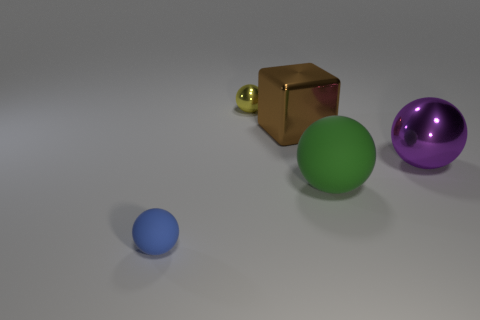There is a yellow sphere that is made of the same material as the large brown object; what is its size?
Your answer should be compact. Small. There is a purple object that is the same size as the brown object; what is it made of?
Make the answer very short. Metal. How many objects are big matte blocks or big metal objects to the right of the large matte ball?
Offer a terse response. 1. Is there another thing of the same shape as the tiny metal thing?
Ensure brevity in your answer.  Yes. There is a thing that is left of the tiny ball behind the tiny blue ball; what size is it?
Ensure brevity in your answer.  Small. What number of shiny objects are either large brown things or large purple objects?
Your answer should be compact. 2. How many small gray matte blocks are there?
Provide a succinct answer. 0. Is the material of the small ball in front of the large green matte object the same as the big ball on the left side of the purple shiny thing?
Provide a short and direct response. Yes. There is another tiny thing that is the same shape as the small blue object; what color is it?
Ensure brevity in your answer.  Yellow. There is a tiny ball that is in front of the big thing that is left of the green matte thing; what is its material?
Provide a short and direct response. Rubber. 